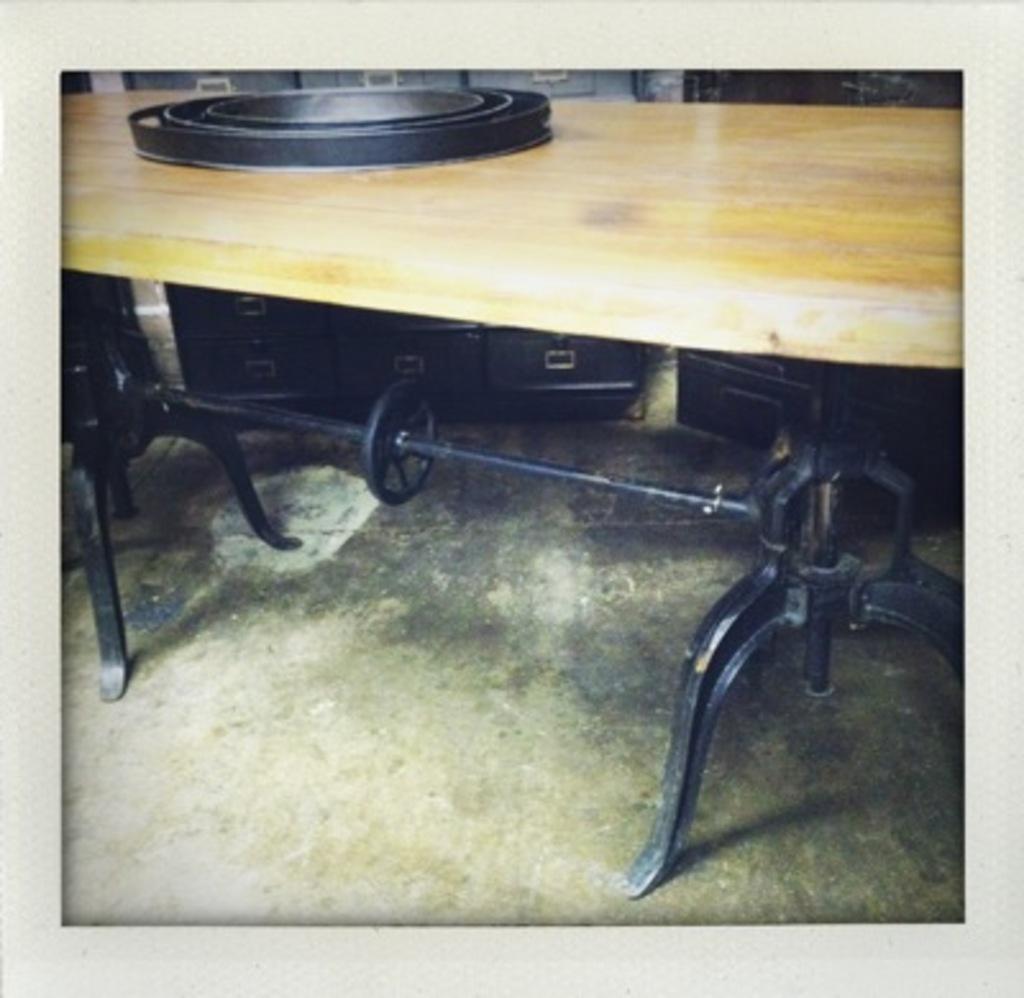Please provide a concise description of this image. In this picture we can see black object on the table and floor. In the background of the image we can see objects. 